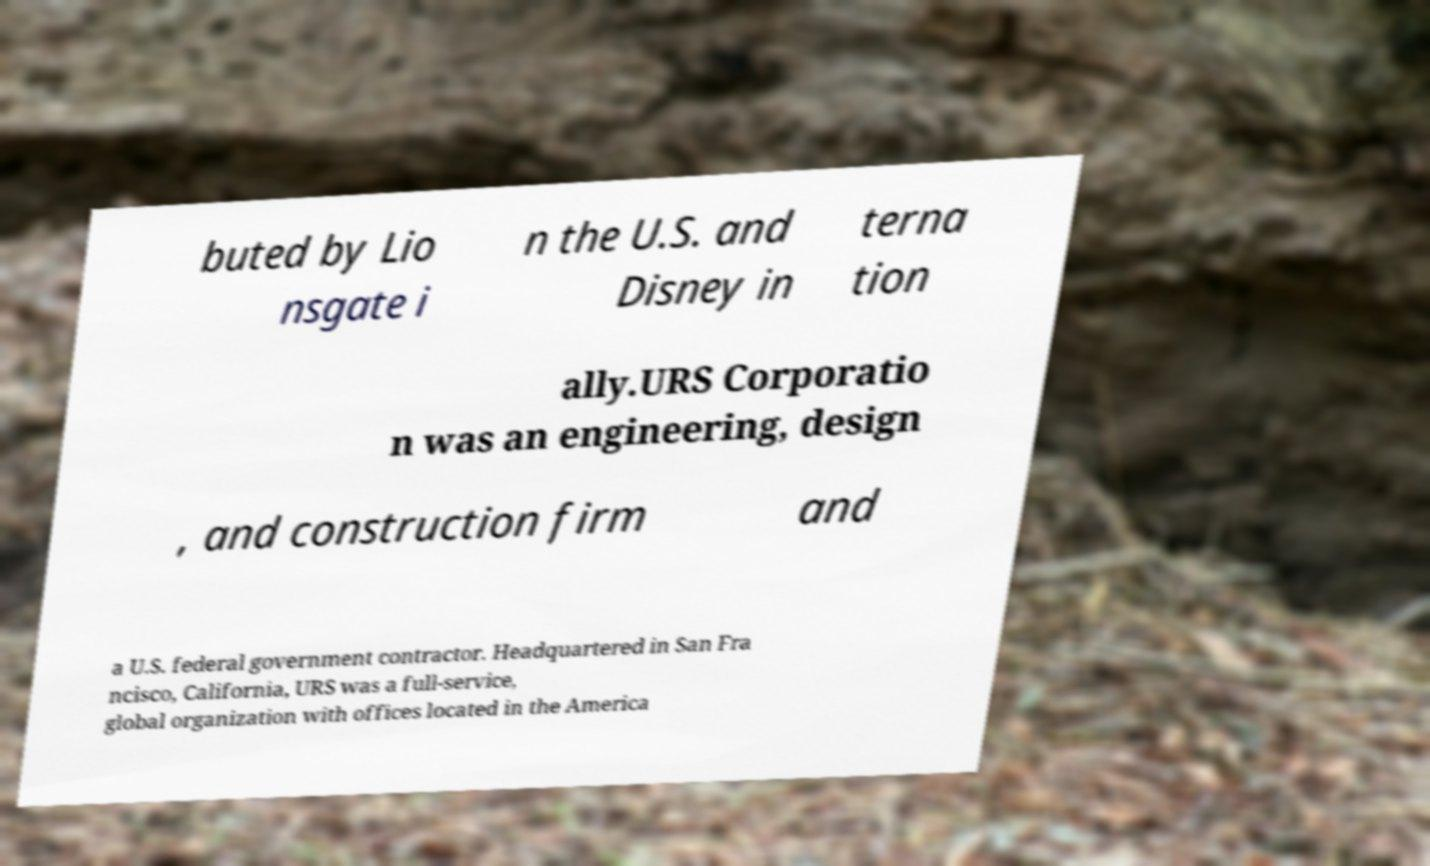Can you accurately transcribe the text from the provided image for me? buted by Lio nsgate i n the U.S. and Disney in terna tion ally.URS Corporatio n was an engineering, design , and construction firm and a U.S. federal government contractor. Headquartered in San Fra ncisco, California, URS was a full-service, global organization with offices located in the America 